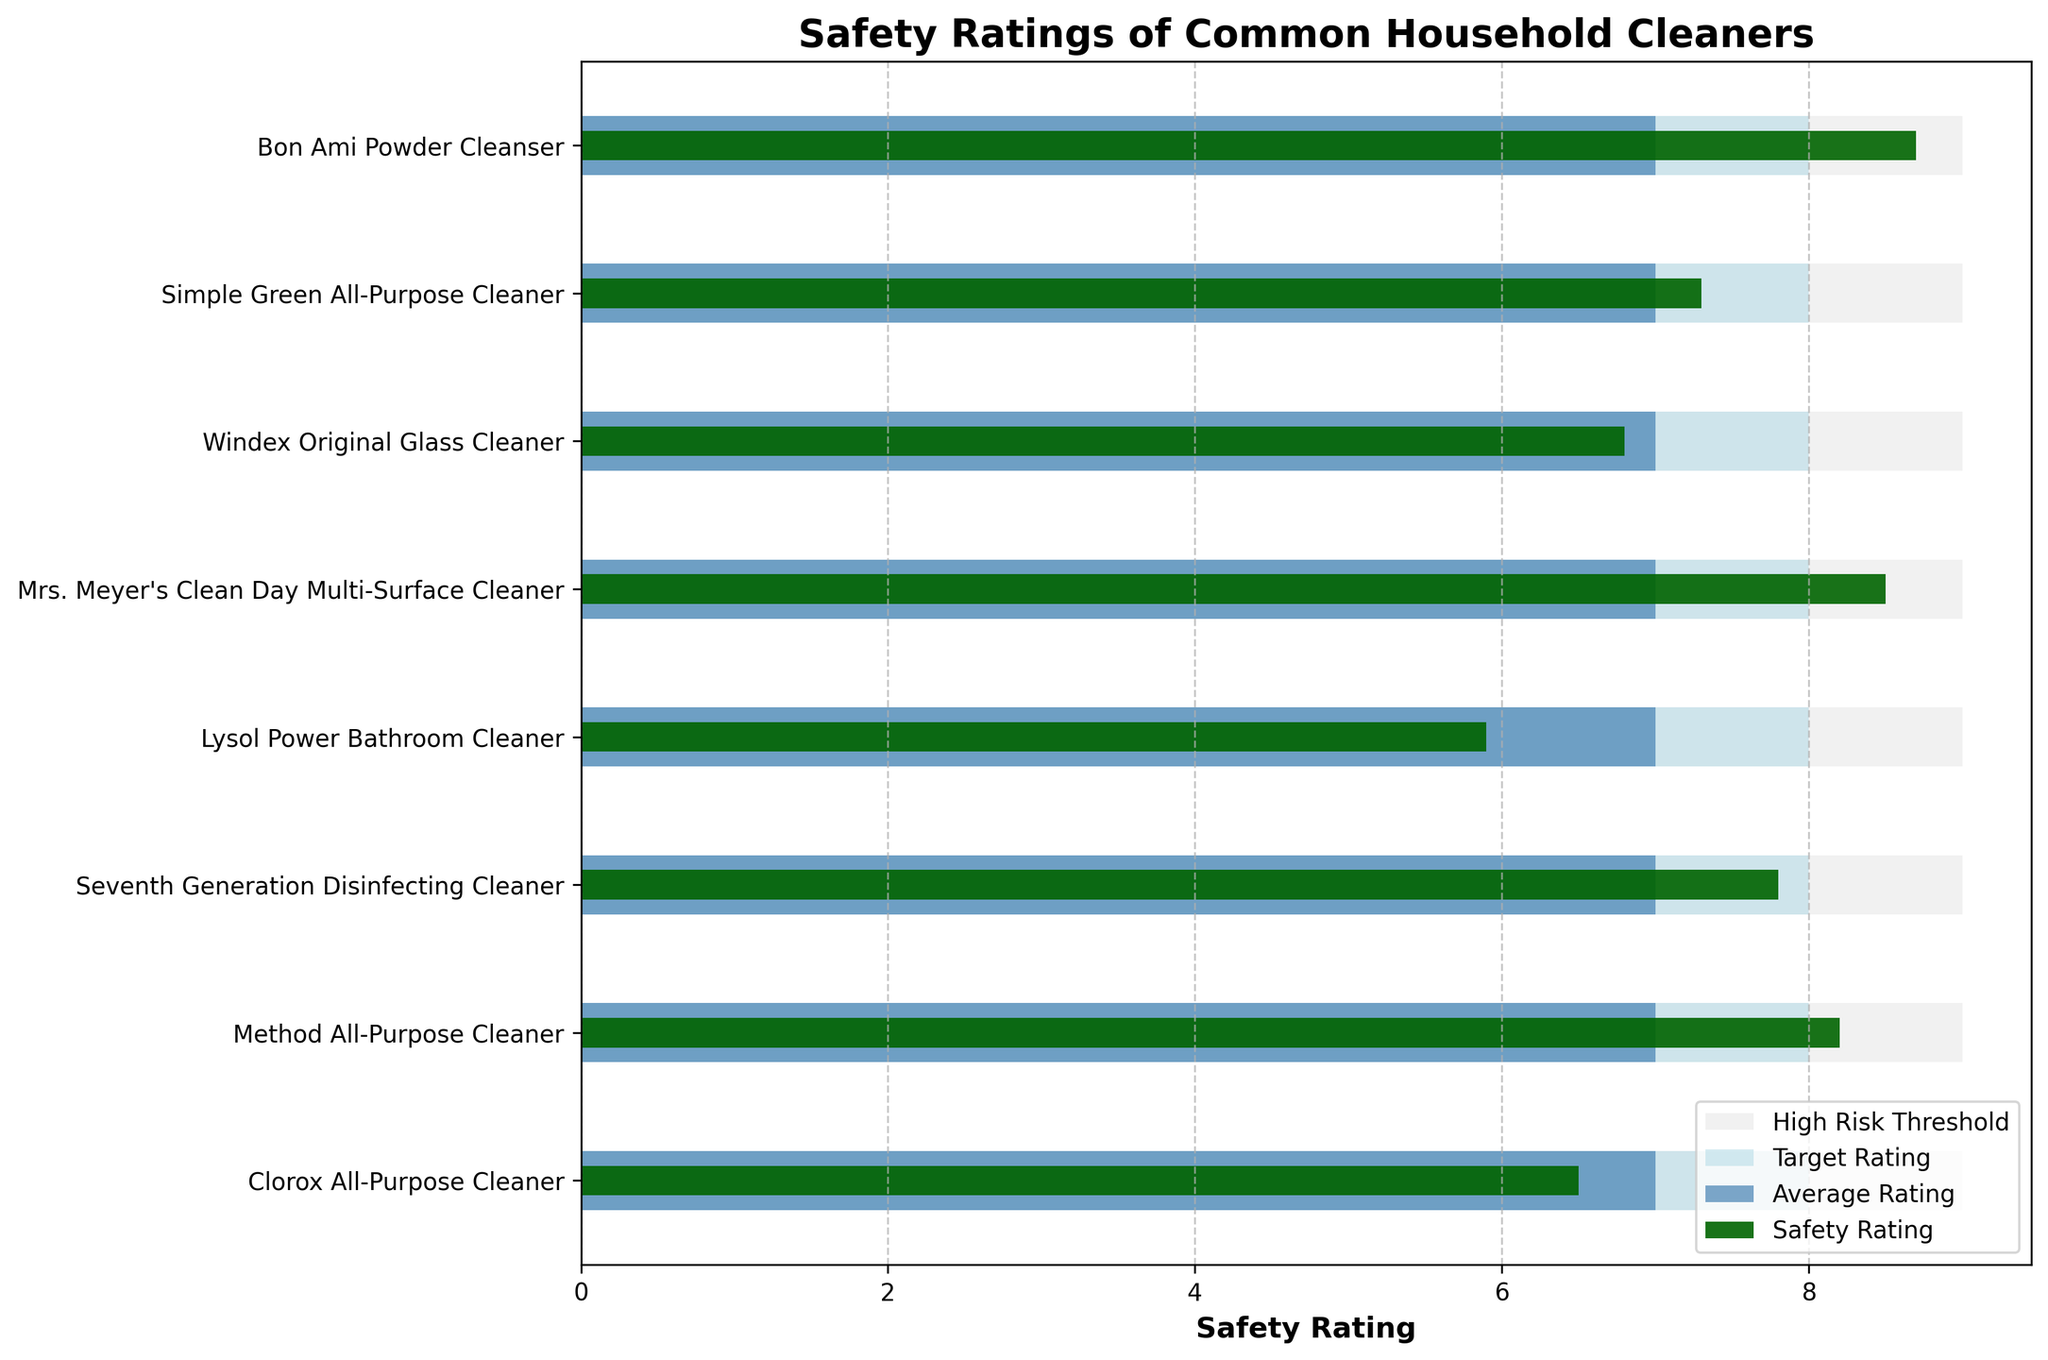What product has the highest safety rating? By looking at the figure, the product with the longest dark green bar represents the highest safety rating.
Answer: Bon Ami Powder Cleanser Which product falls below the average rating? Identify the products whose dark green bars (safety ratings) are shorter than the steel blue bars (average ratings).
Answer: Lysol Power Bathroom Cleaner What is the safety rating of Method All-Purpose Cleaner? Find the product label "Method All-Purpose Cleaner" on the y-axis and trace it to the corresponding dark green bar.
Answer: 8.2 How many products have safety ratings above the target rating? Identify all products where the dark green bar (safety rating) exceeds the light blue bar (target rating).
Answer: 1 (Mrs. Meyer's Clean Day Multi-Surface Cleaner) Which products are close to reaching the high-risk threshold? Compare the dark green bars (safety ratings) with the light gray bars (high-risk thresholds) and see which products are close.
Answer: Clorox All-Purpose Cleaner, Windex Original Glass Cleaner What's the difference in safety rating between Clorox All-Purpose Cleaner and Bon Ami Powder Cleanser? Look at the dark green bars of both products and subtract the safety rating of Clorox All-Purpose Cleaner from Bon Ami Powder Cleanser.
Answer: 2.2 (8.7 - 6.5) How does Mrs. Meyer's safety rating compare with the target rating? Identify the dark green bar (safety rating) and the light blue bar (target rating) for Mrs. Meyer's Clean Day Multi-Surface Cleaner and compare them.
Answer: Higher Which product exceeds the target rating the most? Find the product with the largest difference between its dark green bar (safety rating) and light blue bar (target rating).
Answer: Mrs. Meyer's Clean Day Multi-Surface Cleaner 